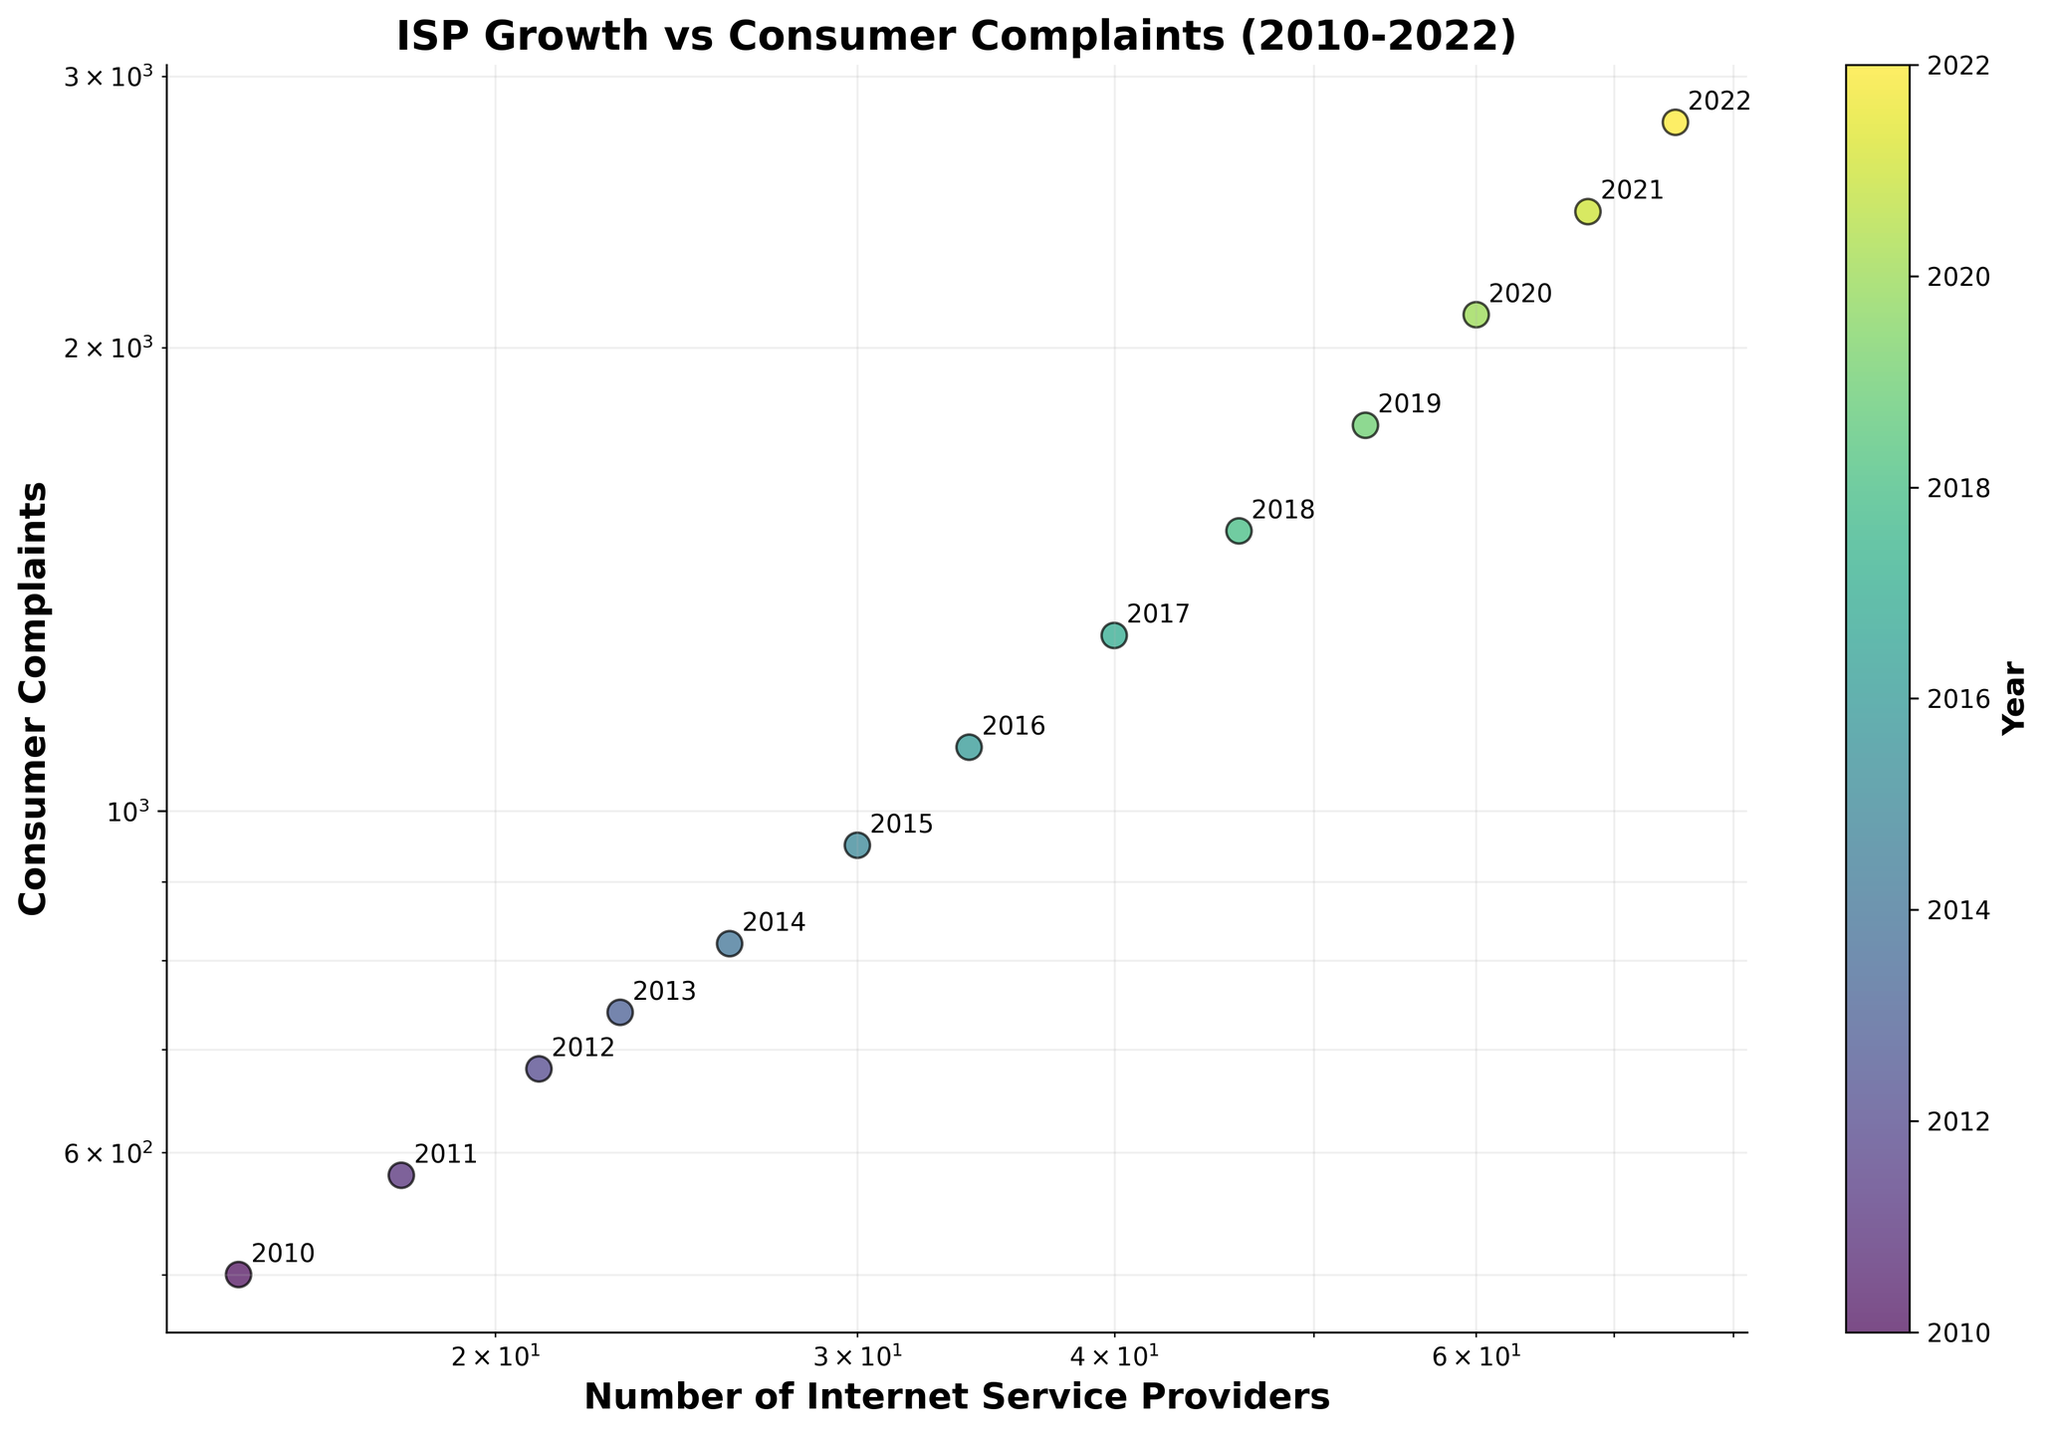How many years are represented in the figure? The figure has points representing data for each year from 2010 to 2022. Count the number of unique years.
Answer: 13 What are the axis labels on the scatter plot? The x-axis label is "Number of Internet Service Providers," and the y-axis label is "Consumer Complaints." These labels are visible on the scatter plot along with the corresponding data distribution.
Answer: "Number of Internet Service Providers" and "Consumer Complaints" Which year had the highest number of internet service providers? Look at the annotations near the point on the x-axis with the highest value. The point with the highest x-coordinate is in 2022.
Answer: 2022 What is the relationship between the number of internet service providers and consumer complaints? Observe the trend of the data points as the number of internet service providers increases. Both the x and y coordinates generally increase, indicating a positive relationship between the number of internet service providers and consumer complaints.
Answer: Positive relationship How does the scatter plot represent the time progression? The scatter plot uses a color gradient to represent the progression of years, with a color bar indicating the year for each data point. This allows viewers to see changes over time.
Answer: Color gradient Is there any year that stands out due to a noticeable change in consumer complaints compared to its previous year? Examine the annotations and the y-coordinates. Considerable increases in consumer complaints can be observed from 2015 to 2016 and from 2019 to 2020, where the data points have larger vertical gaps compared to adjacent years.
Answer: 2015-2016, 2019-2020 How does the color of the data points vary across the years? The scatter plot uses a colormap where earlier years are in darker colors and later years in lighter colors, illustrating data points progressively from darker to lighter shades.
Answer: Darker to lighter Identify the year with approximately 40 Internet Service Providers and its corresponding consumer complaints. Find the data point around 40 on the x-axis, annotate the year marked, and check its y-coordinate. The corresponding year is 2017, with around 1300 consumer complaints.
Answer: 2017 and 1300 Which year shows the largest increase in consumer complaints from the previous year? Compare the vertical distances between consecutive data points' y-coordinates and identify the largest increase. The most significant jump occurs between 2019 and 2020.
Answer: Between 2019 and 2020 What can you infer about the growth of Internet Service Providers and consumer complaints from 2010 to 2022? From 2010 to 2022, both the number of Internet Service Providers and consumer complaints generally increased, as evidenced by the overall upward trend in the scatter plot. This infers that as the number of providers grew, consumer complaints also increased, likely due to a combination of more users and possibly growing dissatisfaction.
Answer: Both increased 